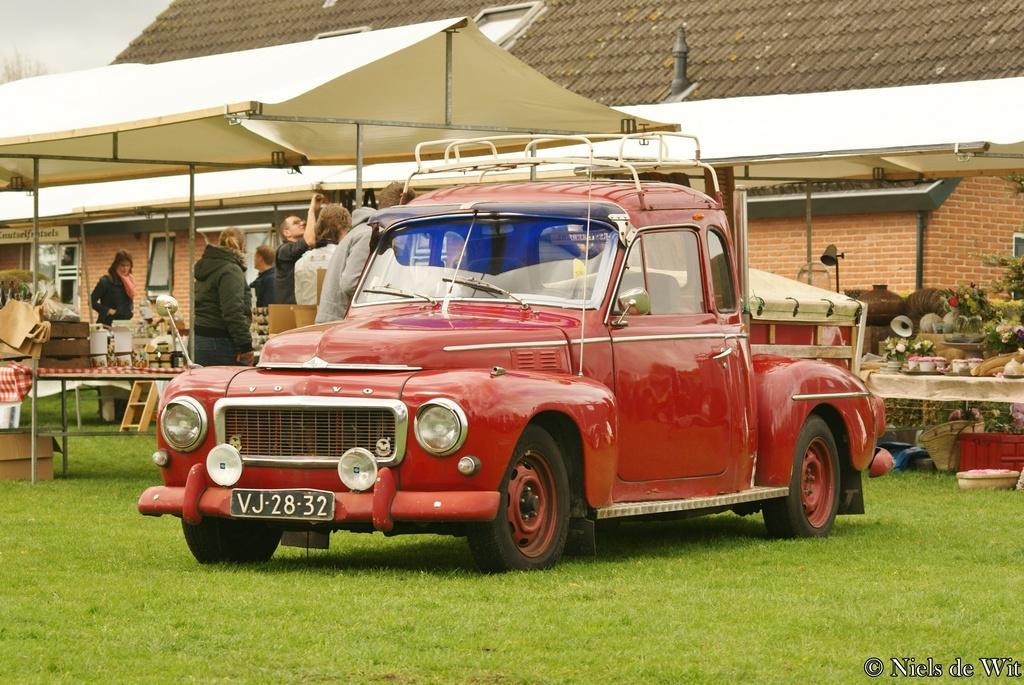Can you describe this image briefly? In the center of the image we can see a car. On the left there are people and we can see tables. There are flower pots and some things placed on the tables. At the top there is a tent. In the background there is a shed. At the bottom there is grass and we can see a cardboard box. 